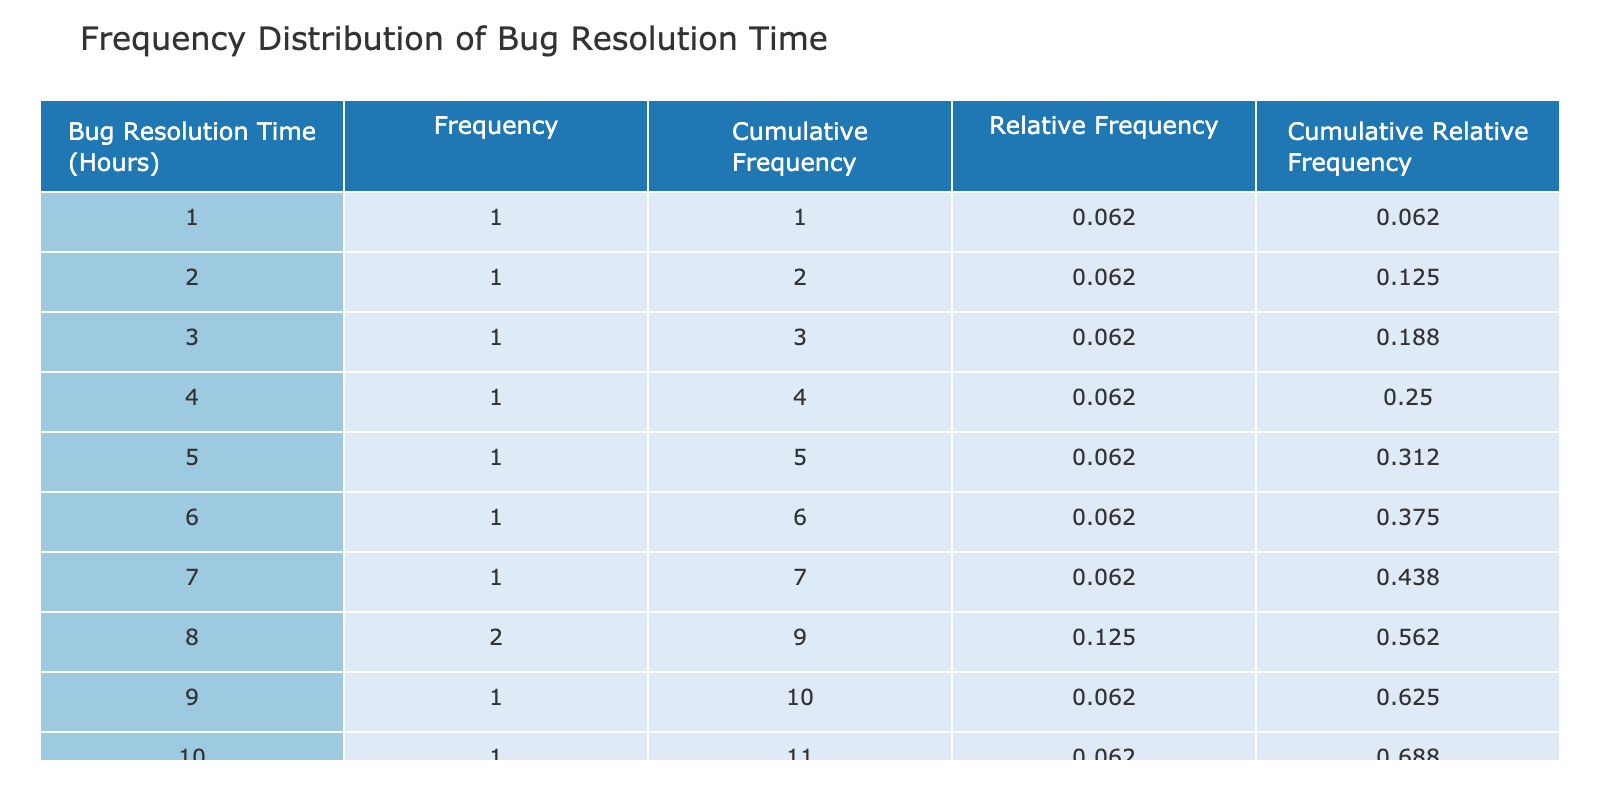What is the highest bug resolution time recorded? The highest bug resolution time listed in the table is 15 hours, which can be found at the top end of the Bug Resolution Time (Hours) column.
Answer: 15 What is the frequency of bugs resolved in 8 hours? In the frequency column, the number corresponding to 8 hours is 2, indicating that two bugs were resolved in that time frame.
Answer: 2 Was there any bug resolved in less than 3 hours? From the table, the minimum bug resolution time shown is 1 hour, so the statement is true.
Answer: Yes What is the cumulative frequency for bugs resolved in 10 hours? To find the cumulative frequency for 10 hours, we sum all frequencies up to and including that value. The individual frequencies for 1, 2, 3, 4, 5, 6, 7, 8, 9, and 10 hours add up to 6.
Answer: 6 What is the relative frequency of bugs resolved in 12 hours? The relative frequency for 12 hours is calculated as the frequency of that value divided by the total count of bugs. Since there is 1 bug resolved in 12 hours and the total number is 15, the relative frequency is 1/15, which equals approximately 0.067.
Answer: 0.067 What is the average bug resolution time across all projects? The total resolution time is calculated by summing all the times: (4 + 8 + 6 + 12 + 5 + 3 + 7 + 10 + 15 + 9 + 2 + 11 + 13 + 1 + 8 + 14) =  100 hours. There are 16 data points, so the average is 100/16, which equals 6.25 hours.
Answer: 6.25 How many bugs were resolved in total across all projects? By reviewing the frequency column, you can count the total number of hours worked on bugs listed, which sums to 16 distinct instances of bug resolution across the projects.
Answer: 16 Is it true that no bugs took longer than 14 hours to resolve? By assessing the table, the highest time reported is 15 hours, therefore the statement is false.
Answer: No What is the cumulative relative frequency for bugs resolved in 6 hours? To find this, we need to consider all bugs resolved in 1, 2, 3, 4, 5, 6 hours and sum their relative frequencies. The cumulative relative frequencies for these values total to roughly 0.467 when adding the individual relative values together.
Answer: 0.467 